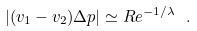Convert formula to latex. <formula><loc_0><loc_0><loc_500><loc_500>| ( { v } _ { 1 } - { v } _ { 2 } ) \Delta { p } | \simeq R e ^ { - 1 / \lambda } \ .</formula> 